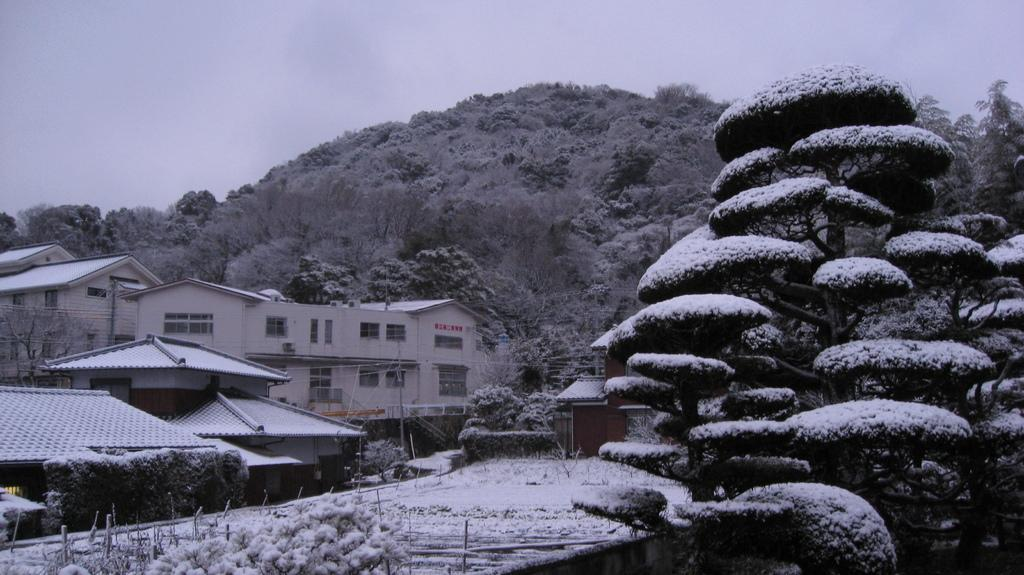What type of natural environment is depicted in the image? There are trees with snow in the image, indicating a winter scene. What structures can be seen in the background of the image? There are houses and a mountain in the background of the image. What is the condition of the sky in the image? The sky is clear in the background of the image. Can you see a balloon being played with in the image? There is no balloon or play activity present in the image. Is there a hook hanging from the trees in the image? There is no hook visible in the image; it features trees with snow, houses, a mountain, and a clear sky. 